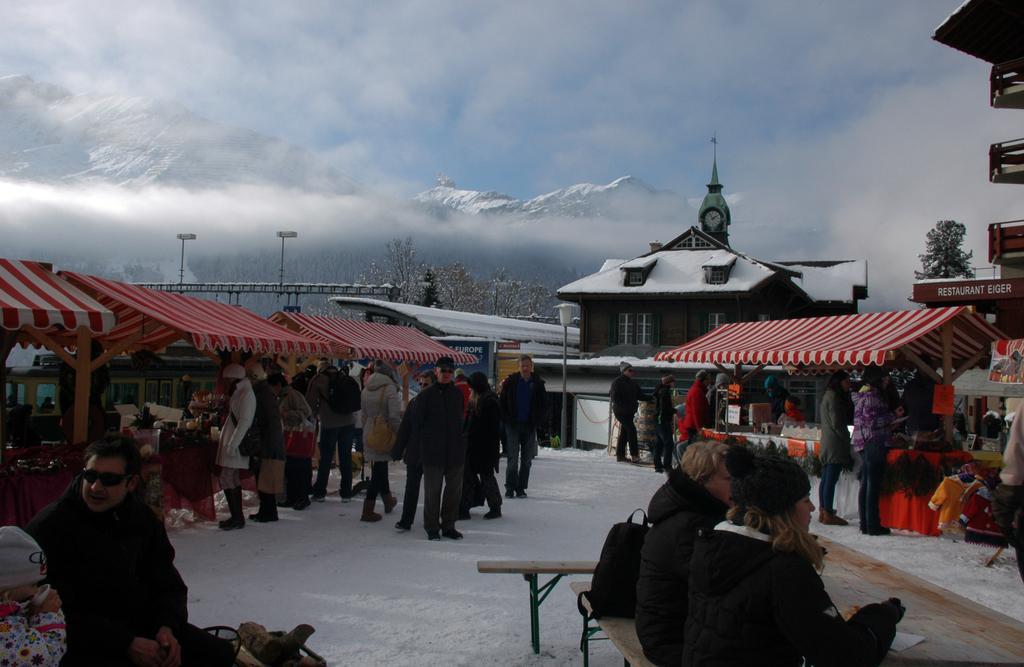Could you give a brief overview of what you see in this image? In this image I can see many people with different color dresses. In-front of few people I can see the tents. In the background I can see the buildings, trees, mountains, clouds and the sky. 